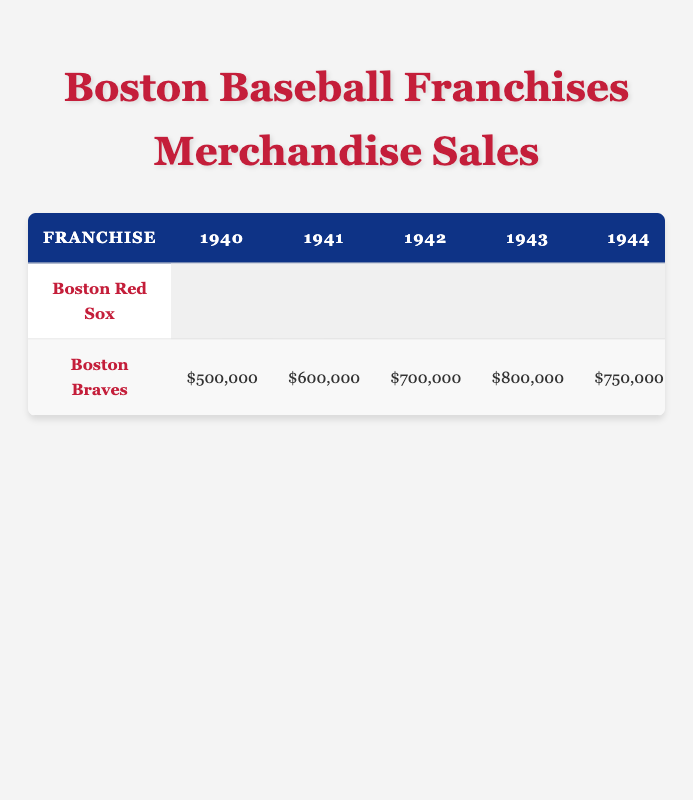What was the revenue from merchandise sales for the Boston Red Sox in 2015? According to the table, in 2015, the revenue generated by the Boston Red Sox from merchandise sales was reported as $30,000,000.
Answer: $30,000,000 What was the total revenue generated by the Boston Braves from 1940 to 1949? To find the total revenue, we will add up the annual sales from 1940 to 1949: $500,000 + $600,000 + $700,000 + $800,000 + $750,000 + $900,000 + $950,000 + $1,000,000 + $1,100,000 + $1,200,000, which totals $8,300,000.
Answer: $8,300,000 Did the Boston Red Sox have higher merchandise sales in 2019 than in 2018? The table shows that in 2018, the Boston Red Sox had revenue of $40,000,000, and in 2019, they had $42,000,000. Therefore, 2019 sales were indeed higher.
Answer: Yes What was the average merchandise sales revenue for the Boston Red Sox from 2010 to 2019? To calculate the average, we sum the revenues from 2010 to 2019, which are: $15,000,000 + $17,000,000 + $19,000,000 + $22,000,000 + $25,000,000 + $30,000,000 + $32,000,000 + $35,000,000 + $40,000,000 + $42,000,000 = $  342,000,000. There are 10 data points, so to find the average, we divide $342,000,000 by 10, resulting in $34,200,000.
Answer: $34,200,000 What year had the highest merchandise revenue for the Boston Red Sox? Reviewing the data for the Boston Red Sox, 2019 showed the highest revenue of $42,000,000, which is the largest figure in their listed years.
Answer: 2019 Is it true that Boston Braves generated more than $1,000,000 in merchandise sales revenue in 1949? According to the table, in 1949, the Boston Braves generated $1,200,000 in revenue, which is indeed greater than $1,000,000. Therefore, the statement is true.
Answer: Yes What is the difference in merchandise sales revenue for the Boston Red Sox between 2013 and 2014? In 2014, the revenue was $25,000,000 and in 2013 it was $22,000,000. The difference is $25,000,000 - $22,000,000 = $3,000,000.
Answer: $3,000,000 In how many years did the Boston Braves increase their merchandise sales year-over-year from 1940 to 1949? By examining the data from the Boston Braves, we see increases in sales from 1940 to 1941, 1941 to 1942, 1942 to 1943, and then decreased in 1944, but resumed increasing till 1949. Therefore, they saw increases in 1940-1941, 1941-1942, 1942-1943, 1945-1946, 1946-1947, 1947-1948, and 1948-1949, totaling 7 years of increases year-over-year.
Answer: 7 years What is the total revenue from merchandise sales for the Boston Red Sox up to 2022? We will sum the revenue from 2010 to 2022: $15,000,000 + $17,000,000 + $19,000,000 + $22,000,000 + $25,000,000 + $30,000,000 + $32,000,000 + $35,000,000 + $40,000,000 + $42,000,000 + $18,000,000 + $30,000,000 + $31,000,000 = $  373,000,000.
Answer: $373,000,000 What was the revenue from merchandise sales in 2020 compared to 2021 for the Boston Red Sox? In 2020, the revenue was $18,000,000 and in 2021 it was $30,000,000. This shows an increase from 2020 to 2021 of $30,000,000 - $18,000,000 = $12,000,000.
Answer: $12,000,000 